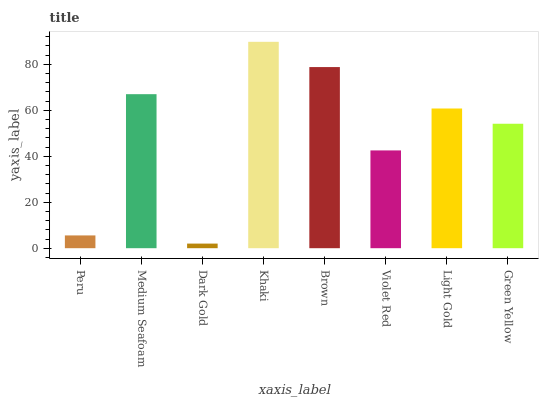Is Dark Gold the minimum?
Answer yes or no. Yes. Is Khaki the maximum?
Answer yes or no. Yes. Is Medium Seafoam the minimum?
Answer yes or no. No. Is Medium Seafoam the maximum?
Answer yes or no. No. Is Medium Seafoam greater than Peru?
Answer yes or no. Yes. Is Peru less than Medium Seafoam?
Answer yes or no. Yes. Is Peru greater than Medium Seafoam?
Answer yes or no. No. Is Medium Seafoam less than Peru?
Answer yes or no. No. Is Light Gold the high median?
Answer yes or no. Yes. Is Green Yellow the low median?
Answer yes or no. Yes. Is Khaki the high median?
Answer yes or no. No. Is Violet Red the low median?
Answer yes or no. No. 